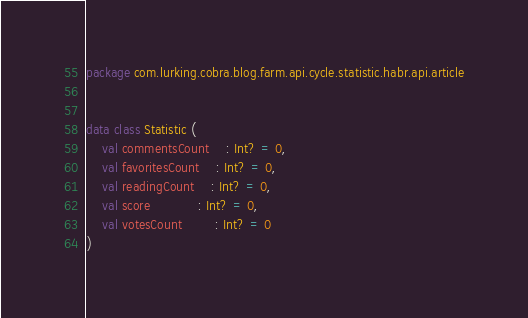<code> <loc_0><loc_0><loc_500><loc_500><_Kotlin_>package com.lurking.cobra.blog.farm.api.cycle.statistic.habr.api.article


data class Statistic (
	val commentsCount 	: Int? = 0,
	val favoritesCount 	: Int? = 0,
	val readingCount 	: Int? = 0,
	val score 			: Int? = 0,
	val votesCount 		: Int? = 0
)</code> 